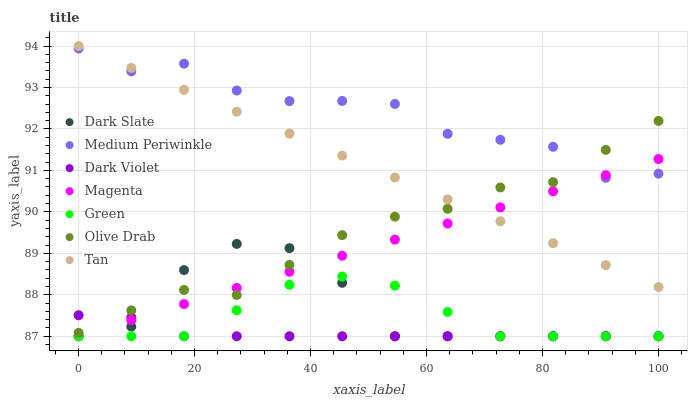Does Dark Violet have the minimum area under the curve?
Answer yes or no. Yes. Does Medium Periwinkle have the maximum area under the curve?
Answer yes or no. Yes. Does Dark Slate have the minimum area under the curve?
Answer yes or no. No. Does Dark Slate have the maximum area under the curve?
Answer yes or no. No. Is Tan the smoothest?
Answer yes or no. Yes. Is Dark Slate the roughest?
Answer yes or no. Yes. Is Dark Violet the smoothest?
Answer yes or no. No. Is Dark Violet the roughest?
Answer yes or no. No. Does Dark Violet have the lowest value?
Answer yes or no. Yes. Does Tan have the lowest value?
Answer yes or no. No. Does Tan have the highest value?
Answer yes or no. Yes. Does Dark Slate have the highest value?
Answer yes or no. No. Is Dark Violet less than Medium Periwinkle?
Answer yes or no. Yes. Is Tan greater than Dark Slate?
Answer yes or no. Yes. Does Dark Slate intersect Dark Violet?
Answer yes or no. Yes. Is Dark Slate less than Dark Violet?
Answer yes or no. No. Is Dark Slate greater than Dark Violet?
Answer yes or no. No. Does Dark Violet intersect Medium Periwinkle?
Answer yes or no. No. 